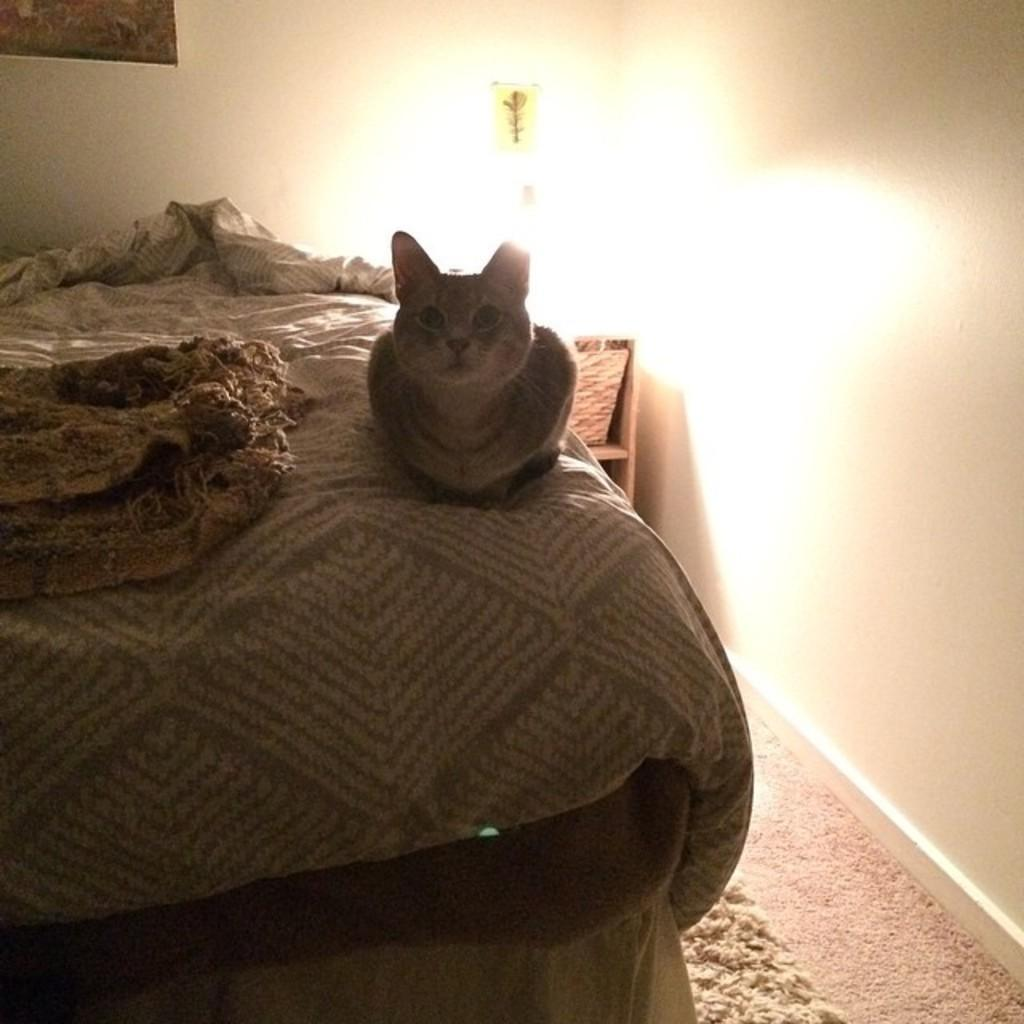What piece of furniture is in the image? There is a bed in the image. What is covering the bed? There is a bed sheet on the bed. What type of animal is present on the bed? A cat is present on the bed. What can be seen in the background of the image? There is a wall in the background of the image. What light source is visible in the image? There is a lamp in the image. What is located at the bottom of the image? There is a mat at the bottom of the image. What type of underwear is the cat wearing in the image? Cats do not wear underwear, and there is no underwear visible in the image. 